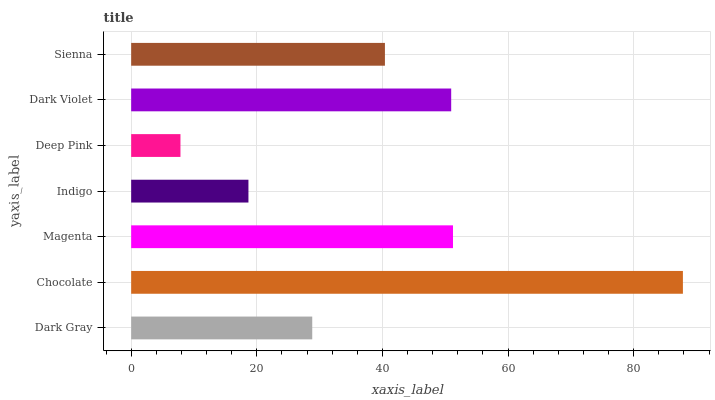Is Deep Pink the minimum?
Answer yes or no. Yes. Is Chocolate the maximum?
Answer yes or no. Yes. Is Magenta the minimum?
Answer yes or no. No. Is Magenta the maximum?
Answer yes or no. No. Is Chocolate greater than Magenta?
Answer yes or no. Yes. Is Magenta less than Chocolate?
Answer yes or no. Yes. Is Magenta greater than Chocolate?
Answer yes or no. No. Is Chocolate less than Magenta?
Answer yes or no. No. Is Sienna the high median?
Answer yes or no. Yes. Is Sienna the low median?
Answer yes or no. Yes. Is Indigo the high median?
Answer yes or no. No. Is Dark Gray the low median?
Answer yes or no. No. 